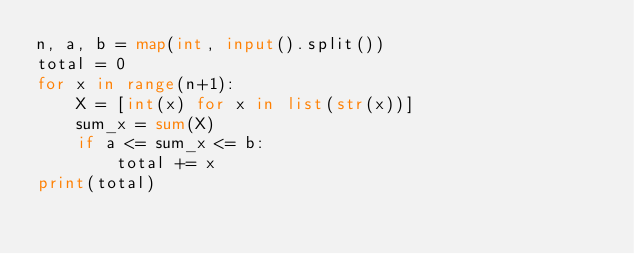<code> <loc_0><loc_0><loc_500><loc_500><_Python_>n, a, b = map(int, input().split())
total = 0
for x in range(n+1):
    X = [int(x) for x in list(str(x))]
    sum_x = sum(X)
    if a <= sum_x <= b:
        total += x
print(total)</code> 